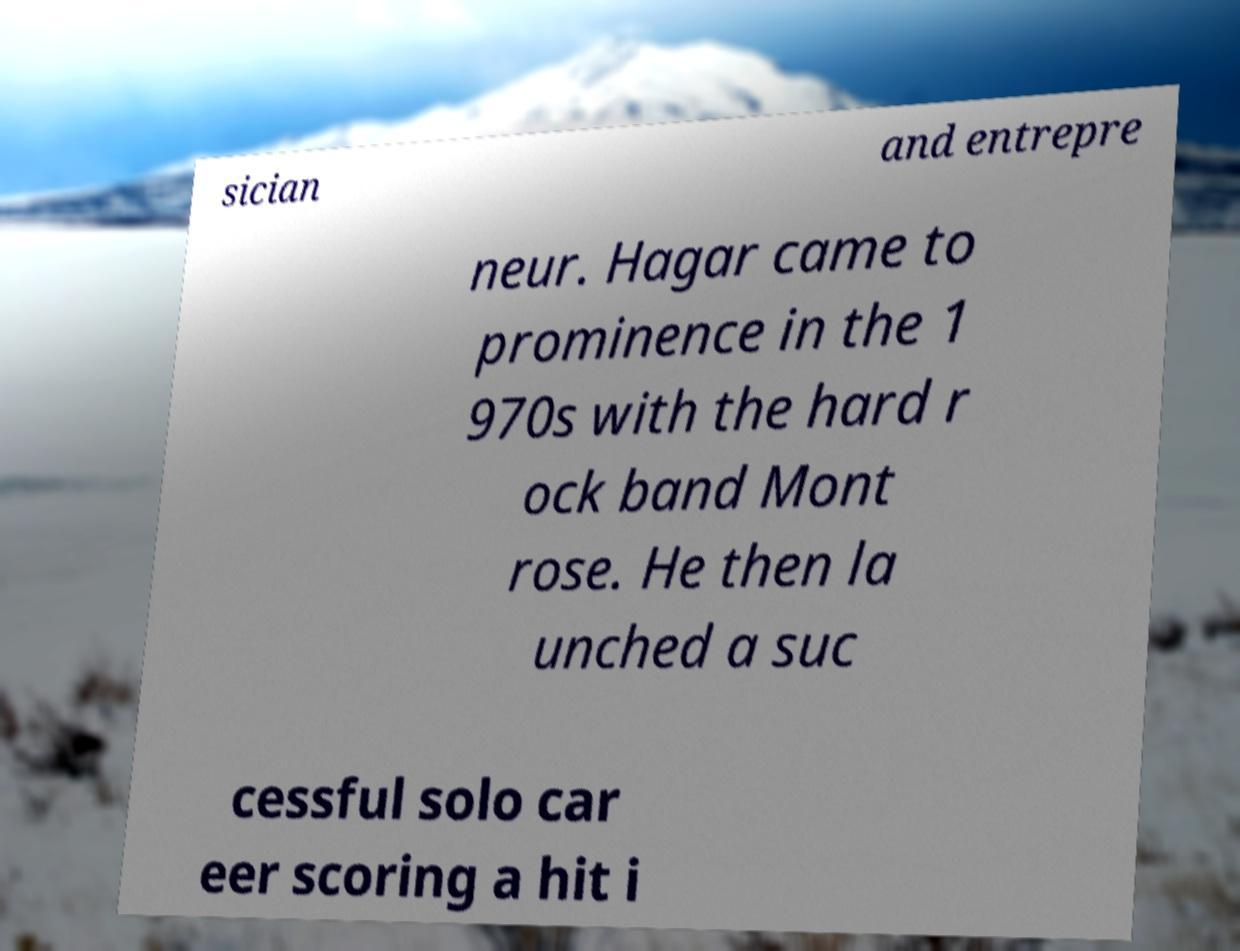Could you extract and type out the text from this image? sician and entrepre neur. Hagar came to prominence in the 1 970s with the hard r ock band Mont rose. He then la unched a suc cessful solo car eer scoring a hit i 